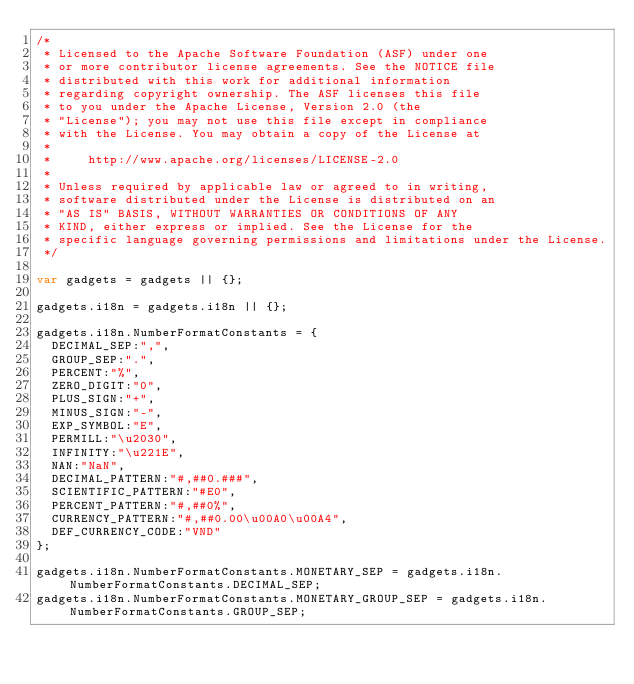Convert code to text. <code><loc_0><loc_0><loc_500><loc_500><_JavaScript_>/*
 * Licensed to the Apache Software Foundation (ASF) under one
 * or more contributor license agreements. See the NOTICE file
 * distributed with this work for additional information
 * regarding copyright ownership. The ASF licenses this file
 * to you under the Apache License, Version 2.0 (the
 * "License"); you may not use this file except in compliance
 * with the License. You may obtain a copy of the License at
 *
 *     http://www.apache.org/licenses/LICENSE-2.0
 *
 * Unless required by applicable law or agreed to in writing,
 * software distributed under the License is distributed on an
 * "AS IS" BASIS, WITHOUT WARRANTIES OR CONDITIONS OF ANY
 * KIND, either express or implied. See the License for the
 * specific language governing permissions and limitations under the License.
 */

var gadgets = gadgets || {};

gadgets.i18n = gadgets.i18n || {};

gadgets.i18n.NumberFormatConstants = {
  DECIMAL_SEP:",",
  GROUP_SEP:".",
  PERCENT:"%",
  ZERO_DIGIT:"0",
  PLUS_SIGN:"+",
  MINUS_SIGN:"-",
  EXP_SYMBOL:"E",
  PERMILL:"\u2030",
  INFINITY:"\u221E",
  NAN:"NaN",
  DECIMAL_PATTERN:"#,##0.###",
  SCIENTIFIC_PATTERN:"#E0",
  PERCENT_PATTERN:"#,##0%",
  CURRENCY_PATTERN:"#,##0.00\u00A0\u00A4",
  DEF_CURRENCY_CODE:"VND"
};

gadgets.i18n.NumberFormatConstants.MONETARY_SEP = gadgets.i18n.NumberFormatConstants.DECIMAL_SEP;
gadgets.i18n.NumberFormatConstants.MONETARY_GROUP_SEP = gadgets.i18n.NumberFormatConstants.GROUP_SEP;
</code> 